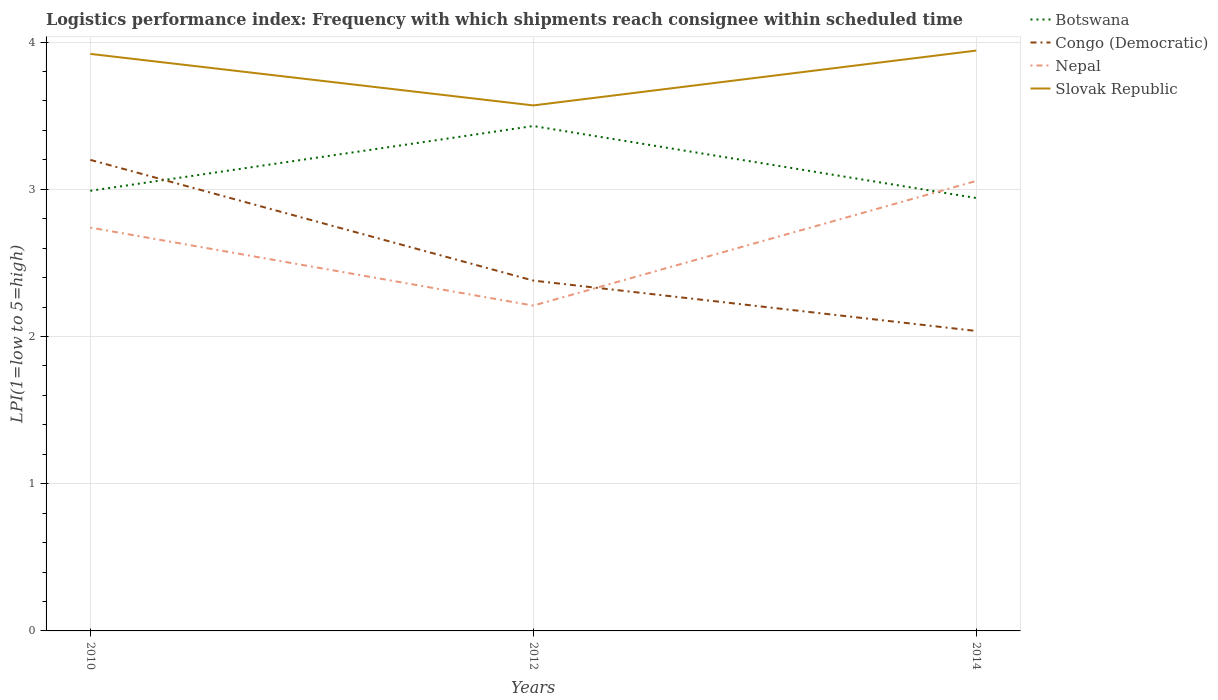Does the line corresponding to Congo (Democratic) intersect with the line corresponding to Nepal?
Ensure brevity in your answer.  Yes. Is the number of lines equal to the number of legend labels?
Offer a terse response. Yes. Across all years, what is the maximum logistics performance index in Nepal?
Offer a very short reply. 2.21. In which year was the logistics performance index in Congo (Democratic) maximum?
Your answer should be very brief. 2014. What is the total logistics performance index in Congo (Democratic) in the graph?
Your answer should be very brief. 0.82. What is the difference between the highest and the second highest logistics performance index in Congo (Democratic)?
Give a very brief answer. 1.16. What is the difference between the highest and the lowest logistics performance index in Congo (Democratic)?
Make the answer very short. 1. Is the logistics performance index in Botswana strictly greater than the logistics performance index in Slovak Republic over the years?
Your answer should be compact. Yes. What is the difference between two consecutive major ticks on the Y-axis?
Provide a short and direct response. 1. Are the values on the major ticks of Y-axis written in scientific E-notation?
Offer a terse response. No. Does the graph contain grids?
Your response must be concise. Yes. What is the title of the graph?
Offer a terse response. Logistics performance index: Frequency with which shipments reach consignee within scheduled time. Does "Namibia" appear as one of the legend labels in the graph?
Your answer should be very brief. No. What is the label or title of the X-axis?
Ensure brevity in your answer.  Years. What is the label or title of the Y-axis?
Offer a terse response. LPI(1=low to 5=high). What is the LPI(1=low to 5=high) in Botswana in 2010?
Make the answer very short. 2.99. What is the LPI(1=low to 5=high) in Congo (Democratic) in 2010?
Offer a terse response. 3.2. What is the LPI(1=low to 5=high) of Nepal in 2010?
Offer a very short reply. 2.74. What is the LPI(1=low to 5=high) of Slovak Republic in 2010?
Your response must be concise. 3.92. What is the LPI(1=low to 5=high) in Botswana in 2012?
Your answer should be very brief. 3.43. What is the LPI(1=low to 5=high) in Congo (Democratic) in 2012?
Give a very brief answer. 2.38. What is the LPI(1=low to 5=high) in Nepal in 2012?
Your answer should be very brief. 2.21. What is the LPI(1=low to 5=high) of Slovak Republic in 2012?
Give a very brief answer. 3.57. What is the LPI(1=low to 5=high) of Botswana in 2014?
Keep it short and to the point. 2.94. What is the LPI(1=low to 5=high) of Congo (Democratic) in 2014?
Offer a terse response. 2.04. What is the LPI(1=low to 5=high) of Nepal in 2014?
Your response must be concise. 3.06. What is the LPI(1=low to 5=high) in Slovak Republic in 2014?
Your response must be concise. 3.94. Across all years, what is the maximum LPI(1=low to 5=high) of Botswana?
Provide a short and direct response. 3.43. Across all years, what is the maximum LPI(1=low to 5=high) of Congo (Democratic)?
Provide a succinct answer. 3.2. Across all years, what is the maximum LPI(1=low to 5=high) in Nepal?
Provide a succinct answer. 3.06. Across all years, what is the maximum LPI(1=low to 5=high) in Slovak Republic?
Keep it short and to the point. 3.94. Across all years, what is the minimum LPI(1=low to 5=high) in Botswana?
Your answer should be compact. 2.94. Across all years, what is the minimum LPI(1=low to 5=high) of Congo (Democratic)?
Give a very brief answer. 2.04. Across all years, what is the minimum LPI(1=low to 5=high) of Nepal?
Offer a terse response. 2.21. Across all years, what is the minimum LPI(1=low to 5=high) of Slovak Republic?
Your answer should be very brief. 3.57. What is the total LPI(1=low to 5=high) of Botswana in the graph?
Provide a succinct answer. 9.36. What is the total LPI(1=low to 5=high) of Congo (Democratic) in the graph?
Provide a succinct answer. 7.62. What is the total LPI(1=low to 5=high) in Nepal in the graph?
Provide a succinct answer. 8.01. What is the total LPI(1=low to 5=high) in Slovak Republic in the graph?
Your response must be concise. 11.43. What is the difference between the LPI(1=low to 5=high) in Botswana in 2010 and that in 2012?
Ensure brevity in your answer.  -0.44. What is the difference between the LPI(1=low to 5=high) of Congo (Democratic) in 2010 and that in 2012?
Ensure brevity in your answer.  0.82. What is the difference between the LPI(1=low to 5=high) in Nepal in 2010 and that in 2012?
Provide a short and direct response. 0.53. What is the difference between the LPI(1=low to 5=high) of Botswana in 2010 and that in 2014?
Offer a very short reply. 0.05. What is the difference between the LPI(1=low to 5=high) in Congo (Democratic) in 2010 and that in 2014?
Ensure brevity in your answer.  1.16. What is the difference between the LPI(1=low to 5=high) in Nepal in 2010 and that in 2014?
Make the answer very short. -0.32. What is the difference between the LPI(1=low to 5=high) in Slovak Republic in 2010 and that in 2014?
Make the answer very short. -0.02. What is the difference between the LPI(1=low to 5=high) of Botswana in 2012 and that in 2014?
Make the answer very short. 0.49. What is the difference between the LPI(1=low to 5=high) of Congo (Democratic) in 2012 and that in 2014?
Your answer should be compact. 0.34. What is the difference between the LPI(1=low to 5=high) of Nepal in 2012 and that in 2014?
Make the answer very short. -0.85. What is the difference between the LPI(1=low to 5=high) in Slovak Republic in 2012 and that in 2014?
Provide a succinct answer. -0.37. What is the difference between the LPI(1=low to 5=high) of Botswana in 2010 and the LPI(1=low to 5=high) of Congo (Democratic) in 2012?
Offer a very short reply. 0.61. What is the difference between the LPI(1=low to 5=high) of Botswana in 2010 and the LPI(1=low to 5=high) of Nepal in 2012?
Ensure brevity in your answer.  0.78. What is the difference between the LPI(1=low to 5=high) of Botswana in 2010 and the LPI(1=low to 5=high) of Slovak Republic in 2012?
Your answer should be very brief. -0.58. What is the difference between the LPI(1=low to 5=high) in Congo (Democratic) in 2010 and the LPI(1=low to 5=high) in Slovak Republic in 2012?
Offer a terse response. -0.37. What is the difference between the LPI(1=low to 5=high) of Nepal in 2010 and the LPI(1=low to 5=high) of Slovak Republic in 2012?
Your response must be concise. -0.83. What is the difference between the LPI(1=low to 5=high) of Botswana in 2010 and the LPI(1=low to 5=high) of Congo (Democratic) in 2014?
Your answer should be very brief. 0.95. What is the difference between the LPI(1=low to 5=high) of Botswana in 2010 and the LPI(1=low to 5=high) of Nepal in 2014?
Offer a very short reply. -0.07. What is the difference between the LPI(1=low to 5=high) of Botswana in 2010 and the LPI(1=low to 5=high) of Slovak Republic in 2014?
Your answer should be very brief. -0.95. What is the difference between the LPI(1=low to 5=high) of Congo (Democratic) in 2010 and the LPI(1=low to 5=high) of Nepal in 2014?
Provide a short and direct response. 0.14. What is the difference between the LPI(1=low to 5=high) of Congo (Democratic) in 2010 and the LPI(1=low to 5=high) of Slovak Republic in 2014?
Offer a terse response. -0.74. What is the difference between the LPI(1=low to 5=high) in Nepal in 2010 and the LPI(1=low to 5=high) in Slovak Republic in 2014?
Offer a terse response. -1.2. What is the difference between the LPI(1=low to 5=high) of Botswana in 2012 and the LPI(1=low to 5=high) of Congo (Democratic) in 2014?
Provide a short and direct response. 1.39. What is the difference between the LPI(1=low to 5=high) in Botswana in 2012 and the LPI(1=low to 5=high) in Nepal in 2014?
Offer a terse response. 0.37. What is the difference between the LPI(1=low to 5=high) in Botswana in 2012 and the LPI(1=low to 5=high) in Slovak Republic in 2014?
Your answer should be very brief. -0.51. What is the difference between the LPI(1=low to 5=high) of Congo (Democratic) in 2012 and the LPI(1=low to 5=high) of Nepal in 2014?
Your answer should be very brief. -0.68. What is the difference between the LPI(1=low to 5=high) in Congo (Democratic) in 2012 and the LPI(1=low to 5=high) in Slovak Republic in 2014?
Keep it short and to the point. -1.56. What is the difference between the LPI(1=low to 5=high) in Nepal in 2012 and the LPI(1=low to 5=high) in Slovak Republic in 2014?
Give a very brief answer. -1.73. What is the average LPI(1=low to 5=high) of Botswana per year?
Give a very brief answer. 3.12. What is the average LPI(1=low to 5=high) in Congo (Democratic) per year?
Give a very brief answer. 2.54. What is the average LPI(1=low to 5=high) of Nepal per year?
Your answer should be very brief. 2.67. What is the average LPI(1=low to 5=high) of Slovak Republic per year?
Provide a short and direct response. 3.81. In the year 2010, what is the difference between the LPI(1=low to 5=high) of Botswana and LPI(1=low to 5=high) of Congo (Democratic)?
Provide a short and direct response. -0.21. In the year 2010, what is the difference between the LPI(1=low to 5=high) of Botswana and LPI(1=low to 5=high) of Nepal?
Your response must be concise. 0.25. In the year 2010, what is the difference between the LPI(1=low to 5=high) of Botswana and LPI(1=low to 5=high) of Slovak Republic?
Keep it short and to the point. -0.93. In the year 2010, what is the difference between the LPI(1=low to 5=high) of Congo (Democratic) and LPI(1=low to 5=high) of Nepal?
Keep it short and to the point. 0.46. In the year 2010, what is the difference between the LPI(1=low to 5=high) of Congo (Democratic) and LPI(1=low to 5=high) of Slovak Republic?
Offer a terse response. -0.72. In the year 2010, what is the difference between the LPI(1=low to 5=high) of Nepal and LPI(1=low to 5=high) of Slovak Republic?
Ensure brevity in your answer.  -1.18. In the year 2012, what is the difference between the LPI(1=low to 5=high) in Botswana and LPI(1=low to 5=high) in Nepal?
Give a very brief answer. 1.22. In the year 2012, what is the difference between the LPI(1=low to 5=high) in Botswana and LPI(1=low to 5=high) in Slovak Republic?
Provide a succinct answer. -0.14. In the year 2012, what is the difference between the LPI(1=low to 5=high) of Congo (Democratic) and LPI(1=low to 5=high) of Nepal?
Give a very brief answer. 0.17. In the year 2012, what is the difference between the LPI(1=low to 5=high) in Congo (Democratic) and LPI(1=low to 5=high) in Slovak Republic?
Keep it short and to the point. -1.19. In the year 2012, what is the difference between the LPI(1=low to 5=high) in Nepal and LPI(1=low to 5=high) in Slovak Republic?
Offer a terse response. -1.36. In the year 2014, what is the difference between the LPI(1=low to 5=high) in Botswana and LPI(1=low to 5=high) in Congo (Democratic)?
Your answer should be compact. 0.9. In the year 2014, what is the difference between the LPI(1=low to 5=high) in Botswana and LPI(1=low to 5=high) in Nepal?
Your answer should be compact. -0.12. In the year 2014, what is the difference between the LPI(1=low to 5=high) of Botswana and LPI(1=low to 5=high) of Slovak Republic?
Offer a very short reply. -1. In the year 2014, what is the difference between the LPI(1=low to 5=high) of Congo (Democratic) and LPI(1=low to 5=high) of Nepal?
Offer a very short reply. -1.02. In the year 2014, what is the difference between the LPI(1=low to 5=high) in Congo (Democratic) and LPI(1=low to 5=high) in Slovak Republic?
Provide a short and direct response. -1.9. In the year 2014, what is the difference between the LPI(1=low to 5=high) of Nepal and LPI(1=low to 5=high) of Slovak Republic?
Offer a terse response. -0.89. What is the ratio of the LPI(1=low to 5=high) in Botswana in 2010 to that in 2012?
Ensure brevity in your answer.  0.87. What is the ratio of the LPI(1=low to 5=high) of Congo (Democratic) in 2010 to that in 2012?
Give a very brief answer. 1.34. What is the ratio of the LPI(1=low to 5=high) in Nepal in 2010 to that in 2012?
Offer a very short reply. 1.24. What is the ratio of the LPI(1=low to 5=high) of Slovak Republic in 2010 to that in 2012?
Ensure brevity in your answer.  1.1. What is the ratio of the LPI(1=low to 5=high) of Botswana in 2010 to that in 2014?
Provide a succinct answer. 1.02. What is the ratio of the LPI(1=low to 5=high) in Congo (Democratic) in 2010 to that in 2014?
Make the answer very short. 1.57. What is the ratio of the LPI(1=low to 5=high) of Nepal in 2010 to that in 2014?
Provide a short and direct response. 0.9. What is the ratio of the LPI(1=low to 5=high) of Slovak Republic in 2010 to that in 2014?
Your answer should be compact. 0.99. What is the ratio of the LPI(1=low to 5=high) of Botswana in 2012 to that in 2014?
Keep it short and to the point. 1.17. What is the ratio of the LPI(1=low to 5=high) of Congo (Democratic) in 2012 to that in 2014?
Offer a very short reply. 1.17. What is the ratio of the LPI(1=low to 5=high) in Nepal in 2012 to that in 2014?
Offer a very short reply. 0.72. What is the ratio of the LPI(1=low to 5=high) of Slovak Republic in 2012 to that in 2014?
Your answer should be compact. 0.91. What is the difference between the highest and the second highest LPI(1=low to 5=high) of Botswana?
Your answer should be very brief. 0.44. What is the difference between the highest and the second highest LPI(1=low to 5=high) in Congo (Democratic)?
Offer a very short reply. 0.82. What is the difference between the highest and the second highest LPI(1=low to 5=high) of Nepal?
Keep it short and to the point. 0.32. What is the difference between the highest and the second highest LPI(1=low to 5=high) in Slovak Republic?
Give a very brief answer. 0.02. What is the difference between the highest and the lowest LPI(1=low to 5=high) of Botswana?
Ensure brevity in your answer.  0.49. What is the difference between the highest and the lowest LPI(1=low to 5=high) of Congo (Democratic)?
Your answer should be very brief. 1.16. What is the difference between the highest and the lowest LPI(1=low to 5=high) in Nepal?
Your answer should be compact. 0.85. What is the difference between the highest and the lowest LPI(1=low to 5=high) of Slovak Republic?
Ensure brevity in your answer.  0.37. 